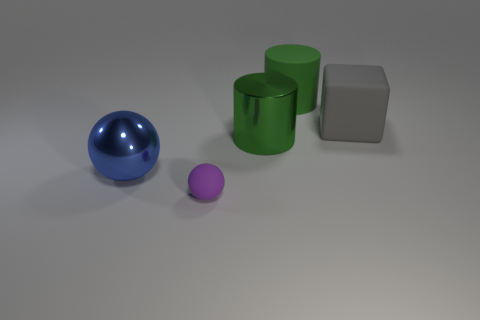Subtract all green blocks. Subtract all blue cylinders. How many blocks are left? 1 Add 4 gray matte blocks. How many objects exist? 9 Subtract all cylinders. How many objects are left? 3 Add 4 large matte cubes. How many large matte cubes are left? 5 Add 2 cylinders. How many cylinders exist? 4 Subtract 1 blue spheres. How many objects are left? 4 Subtract all large blue metallic balls. Subtract all tiny purple matte objects. How many objects are left? 3 